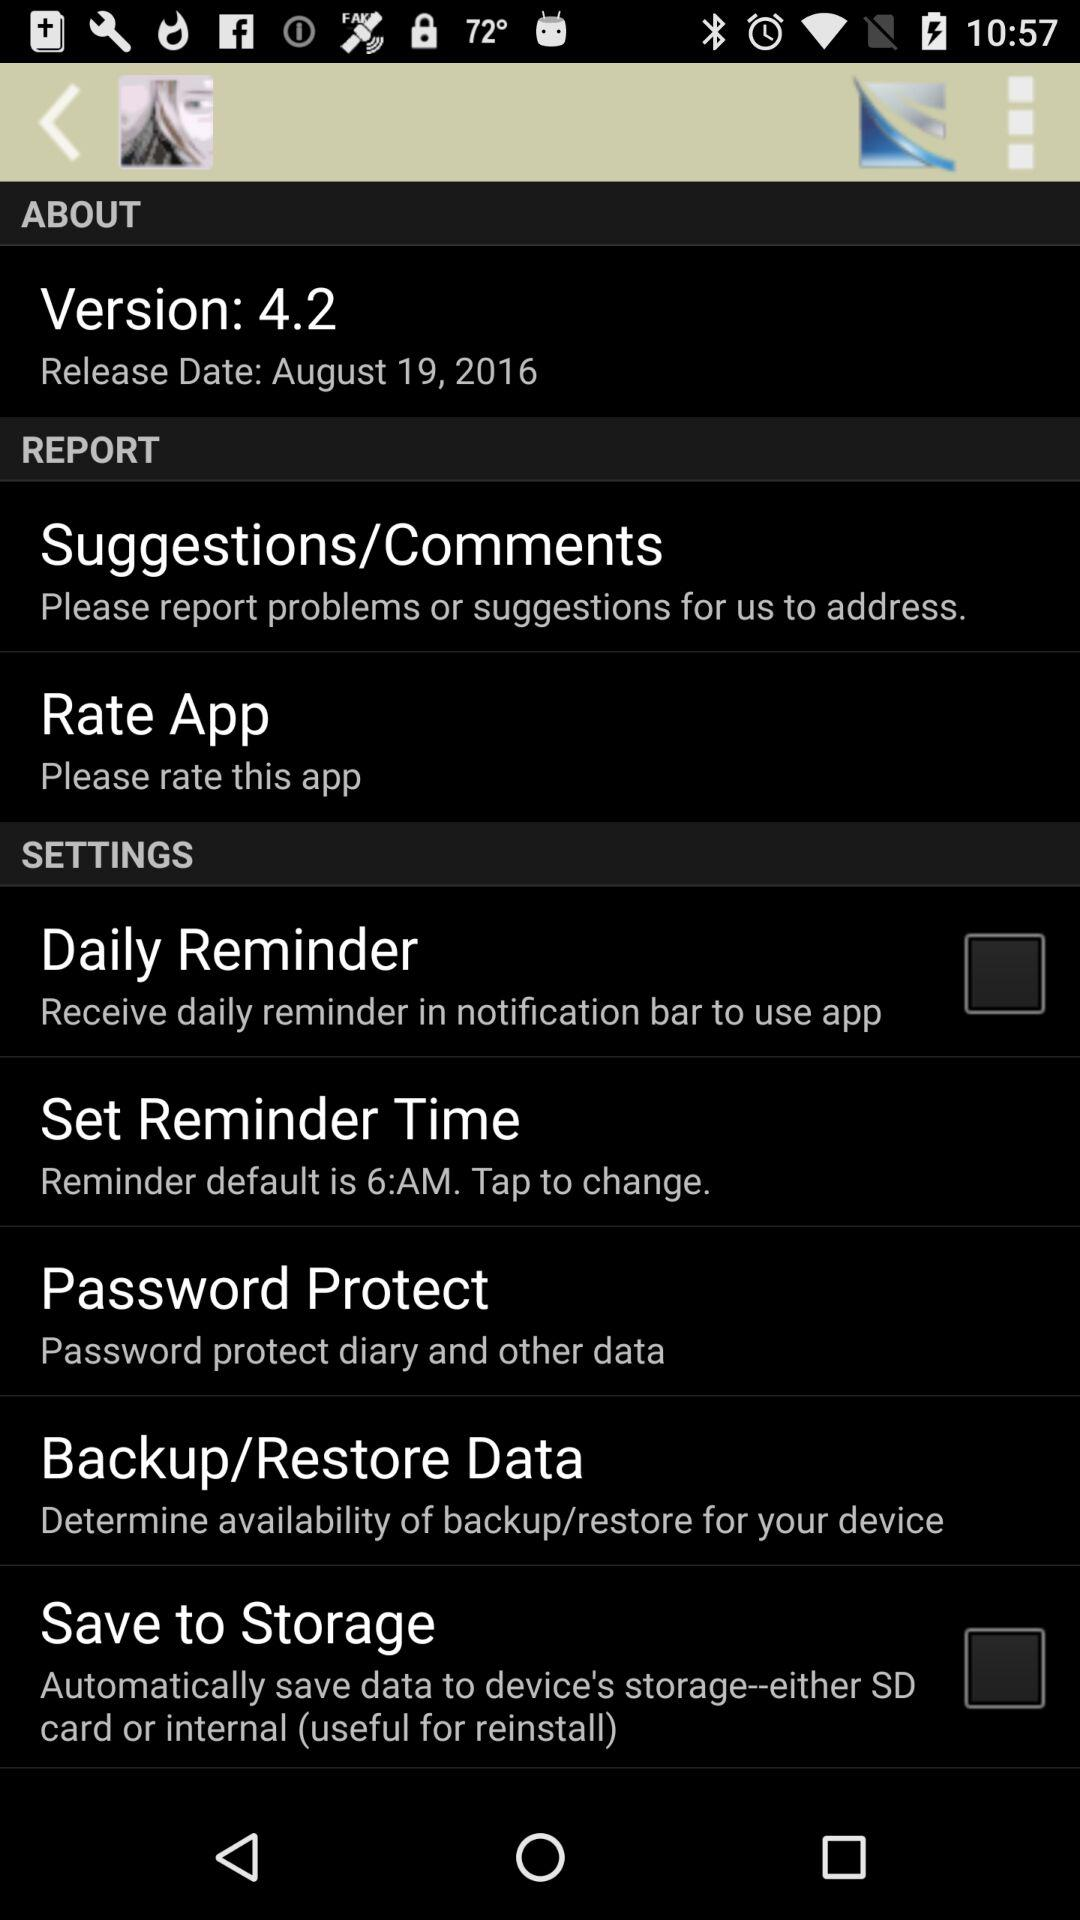What is the release date? The release date is August 19, 2016. 